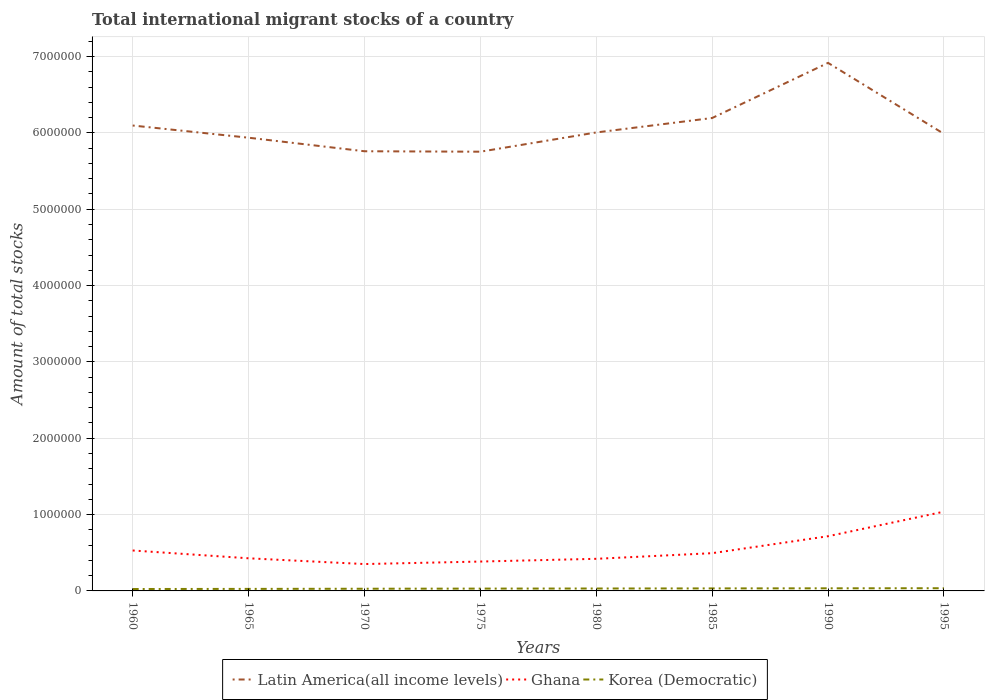Does the line corresponding to Korea (Democratic) intersect with the line corresponding to Latin America(all income levels)?
Offer a terse response. No. Across all years, what is the maximum amount of total stocks in in Korea (Democratic)?
Offer a very short reply. 2.51e+04. In which year was the amount of total stocks in in Korea (Democratic) maximum?
Your response must be concise. 1960. What is the total amount of total stocks in in Korea (Democratic) in the graph?
Your response must be concise. -1243. What is the difference between the highest and the second highest amount of total stocks in in Korea (Democratic)?
Your answer should be very brief. 1.02e+04. How many years are there in the graph?
Your response must be concise. 8. Where does the legend appear in the graph?
Your response must be concise. Bottom center. How many legend labels are there?
Keep it short and to the point. 3. What is the title of the graph?
Offer a terse response. Total international migrant stocks of a country. What is the label or title of the Y-axis?
Give a very brief answer. Amount of total stocks. What is the Amount of total stocks in Latin America(all income levels) in 1960?
Provide a short and direct response. 6.10e+06. What is the Amount of total stocks in Ghana in 1960?
Give a very brief answer. 5.30e+05. What is the Amount of total stocks in Korea (Democratic) in 1960?
Offer a terse response. 2.51e+04. What is the Amount of total stocks in Latin America(all income levels) in 1965?
Keep it short and to the point. 5.94e+06. What is the Amount of total stocks of Ghana in 1965?
Your response must be concise. 4.27e+05. What is the Amount of total stocks of Korea (Democratic) in 1965?
Your response must be concise. 2.66e+04. What is the Amount of total stocks of Latin America(all income levels) in 1970?
Keep it short and to the point. 5.76e+06. What is the Amount of total stocks of Ghana in 1970?
Keep it short and to the point. 3.52e+05. What is the Amount of total stocks in Korea (Democratic) in 1970?
Your answer should be very brief. 2.86e+04. What is the Amount of total stocks of Latin America(all income levels) in 1975?
Offer a very short reply. 5.75e+06. What is the Amount of total stocks of Ghana in 1975?
Give a very brief answer. 3.85e+05. What is the Amount of total stocks in Korea (Democratic) in 1975?
Give a very brief answer. 3.03e+04. What is the Amount of total stocks in Latin America(all income levels) in 1980?
Your answer should be very brief. 6.01e+06. What is the Amount of total stocks in Ghana in 1980?
Your answer should be compact. 4.21e+05. What is the Amount of total stocks in Korea (Democratic) in 1980?
Ensure brevity in your answer.  3.16e+04. What is the Amount of total stocks of Latin America(all income levels) in 1985?
Your answer should be very brief. 6.20e+06. What is the Amount of total stocks of Ghana in 1985?
Your answer should be very brief. 4.94e+05. What is the Amount of total stocks of Korea (Democratic) in 1985?
Your answer should be very brief. 3.29e+04. What is the Amount of total stocks in Latin America(all income levels) in 1990?
Make the answer very short. 6.92e+06. What is the Amount of total stocks of Ghana in 1990?
Your answer should be very brief. 7.17e+05. What is the Amount of total stocks of Korea (Democratic) in 1990?
Make the answer very short. 3.41e+04. What is the Amount of total stocks of Latin America(all income levels) in 1995?
Keep it short and to the point. 5.99e+06. What is the Amount of total stocks in Ghana in 1995?
Keep it short and to the point. 1.04e+06. What is the Amount of total stocks in Korea (Democratic) in 1995?
Your answer should be very brief. 3.53e+04. Across all years, what is the maximum Amount of total stocks in Latin America(all income levels)?
Give a very brief answer. 6.92e+06. Across all years, what is the maximum Amount of total stocks in Ghana?
Ensure brevity in your answer.  1.04e+06. Across all years, what is the maximum Amount of total stocks in Korea (Democratic)?
Your response must be concise. 3.53e+04. Across all years, what is the minimum Amount of total stocks of Latin America(all income levels)?
Give a very brief answer. 5.75e+06. Across all years, what is the minimum Amount of total stocks in Ghana?
Provide a succinct answer. 3.52e+05. Across all years, what is the minimum Amount of total stocks in Korea (Democratic)?
Ensure brevity in your answer.  2.51e+04. What is the total Amount of total stocks in Latin America(all income levels) in the graph?
Keep it short and to the point. 4.87e+07. What is the total Amount of total stocks in Ghana in the graph?
Keep it short and to the point. 4.36e+06. What is the total Amount of total stocks of Korea (Democratic) in the graph?
Your response must be concise. 2.44e+05. What is the difference between the Amount of total stocks in Latin America(all income levels) in 1960 and that in 1965?
Give a very brief answer. 1.60e+05. What is the difference between the Amount of total stocks in Ghana in 1960 and that in 1965?
Provide a short and direct response. 1.02e+05. What is the difference between the Amount of total stocks in Korea (Democratic) in 1960 and that in 1965?
Make the answer very short. -1524. What is the difference between the Amount of total stocks in Latin America(all income levels) in 1960 and that in 1970?
Keep it short and to the point. 3.37e+05. What is the difference between the Amount of total stocks in Ghana in 1960 and that in 1970?
Offer a terse response. 1.78e+05. What is the difference between the Amount of total stocks of Korea (Democratic) in 1960 and that in 1970?
Provide a succinct answer. -3496. What is the difference between the Amount of total stocks of Latin America(all income levels) in 1960 and that in 1975?
Keep it short and to the point. 3.43e+05. What is the difference between the Amount of total stocks of Ghana in 1960 and that in 1975?
Your response must be concise. 1.45e+05. What is the difference between the Amount of total stocks in Korea (Democratic) in 1960 and that in 1975?
Offer a terse response. -5273. What is the difference between the Amount of total stocks in Latin America(all income levels) in 1960 and that in 1980?
Keep it short and to the point. 9.09e+04. What is the difference between the Amount of total stocks of Ghana in 1960 and that in 1980?
Offer a terse response. 1.09e+05. What is the difference between the Amount of total stocks in Korea (Democratic) in 1960 and that in 1980?
Give a very brief answer. -6516. What is the difference between the Amount of total stocks in Latin America(all income levels) in 1960 and that in 1985?
Provide a succinct answer. -9.84e+04. What is the difference between the Amount of total stocks of Ghana in 1960 and that in 1985?
Keep it short and to the point. 3.53e+04. What is the difference between the Amount of total stocks in Korea (Democratic) in 1960 and that in 1985?
Keep it short and to the point. -7787. What is the difference between the Amount of total stocks of Latin America(all income levels) in 1960 and that in 1990?
Give a very brief answer. -8.21e+05. What is the difference between the Amount of total stocks in Ghana in 1960 and that in 1990?
Your response must be concise. -1.87e+05. What is the difference between the Amount of total stocks in Korea (Democratic) in 1960 and that in 1990?
Provide a succinct answer. -9031. What is the difference between the Amount of total stocks of Latin America(all income levels) in 1960 and that in 1995?
Provide a succinct answer. 1.09e+05. What is the difference between the Amount of total stocks in Ghana in 1960 and that in 1995?
Your answer should be compact. -5.09e+05. What is the difference between the Amount of total stocks of Korea (Democratic) in 1960 and that in 1995?
Keep it short and to the point. -1.02e+04. What is the difference between the Amount of total stocks of Latin America(all income levels) in 1965 and that in 1970?
Offer a very short reply. 1.77e+05. What is the difference between the Amount of total stocks in Ghana in 1965 and that in 1970?
Your response must be concise. 7.54e+04. What is the difference between the Amount of total stocks in Korea (Democratic) in 1965 and that in 1970?
Provide a succinct answer. -1972. What is the difference between the Amount of total stocks of Latin America(all income levels) in 1965 and that in 1975?
Keep it short and to the point. 1.83e+05. What is the difference between the Amount of total stocks in Ghana in 1965 and that in 1975?
Offer a terse response. 4.26e+04. What is the difference between the Amount of total stocks of Korea (Democratic) in 1965 and that in 1975?
Offer a very short reply. -3749. What is the difference between the Amount of total stocks in Latin America(all income levels) in 1965 and that in 1980?
Keep it short and to the point. -6.88e+04. What is the difference between the Amount of total stocks in Ghana in 1965 and that in 1980?
Offer a terse response. 6763. What is the difference between the Amount of total stocks of Korea (Democratic) in 1965 and that in 1980?
Provide a succinct answer. -4992. What is the difference between the Amount of total stocks in Latin America(all income levels) in 1965 and that in 1985?
Your answer should be compact. -2.58e+05. What is the difference between the Amount of total stocks of Ghana in 1965 and that in 1985?
Your response must be concise. -6.70e+04. What is the difference between the Amount of total stocks in Korea (Democratic) in 1965 and that in 1985?
Offer a terse response. -6263. What is the difference between the Amount of total stocks of Latin America(all income levels) in 1965 and that in 1990?
Offer a terse response. -9.80e+05. What is the difference between the Amount of total stocks of Ghana in 1965 and that in 1990?
Your response must be concise. -2.89e+05. What is the difference between the Amount of total stocks of Korea (Democratic) in 1965 and that in 1990?
Offer a terse response. -7507. What is the difference between the Amount of total stocks in Latin America(all income levels) in 1965 and that in 1995?
Provide a succinct answer. -5.05e+04. What is the difference between the Amount of total stocks in Ghana in 1965 and that in 1995?
Provide a succinct answer. -6.11e+05. What is the difference between the Amount of total stocks of Korea (Democratic) in 1965 and that in 1995?
Provide a succinct answer. -8695. What is the difference between the Amount of total stocks in Latin America(all income levels) in 1970 and that in 1975?
Keep it short and to the point. 5813. What is the difference between the Amount of total stocks in Ghana in 1970 and that in 1975?
Keep it short and to the point. -3.28e+04. What is the difference between the Amount of total stocks in Korea (Democratic) in 1970 and that in 1975?
Your answer should be compact. -1777. What is the difference between the Amount of total stocks in Latin America(all income levels) in 1970 and that in 1980?
Keep it short and to the point. -2.46e+05. What is the difference between the Amount of total stocks in Ghana in 1970 and that in 1980?
Offer a very short reply. -6.87e+04. What is the difference between the Amount of total stocks in Korea (Democratic) in 1970 and that in 1980?
Your response must be concise. -3020. What is the difference between the Amount of total stocks in Latin America(all income levels) in 1970 and that in 1985?
Your answer should be very brief. -4.36e+05. What is the difference between the Amount of total stocks of Ghana in 1970 and that in 1985?
Provide a succinct answer. -1.42e+05. What is the difference between the Amount of total stocks of Korea (Democratic) in 1970 and that in 1985?
Give a very brief answer. -4291. What is the difference between the Amount of total stocks in Latin America(all income levels) in 1970 and that in 1990?
Your answer should be very brief. -1.16e+06. What is the difference between the Amount of total stocks of Ghana in 1970 and that in 1990?
Your answer should be compact. -3.65e+05. What is the difference between the Amount of total stocks of Korea (Democratic) in 1970 and that in 1990?
Provide a succinct answer. -5535. What is the difference between the Amount of total stocks in Latin America(all income levels) in 1970 and that in 1995?
Make the answer very short. -2.28e+05. What is the difference between the Amount of total stocks of Ghana in 1970 and that in 1995?
Offer a terse response. -6.86e+05. What is the difference between the Amount of total stocks in Korea (Democratic) in 1970 and that in 1995?
Give a very brief answer. -6723. What is the difference between the Amount of total stocks of Latin America(all income levels) in 1975 and that in 1980?
Offer a terse response. -2.52e+05. What is the difference between the Amount of total stocks in Ghana in 1975 and that in 1980?
Give a very brief answer. -3.59e+04. What is the difference between the Amount of total stocks in Korea (Democratic) in 1975 and that in 1980?
Your answer should be compact. -1243. What is the difference between the Amount of total stocks in Latin America(all income levels) in 1975 and that in 1985?
Give a very brief answer. -4.41e+05. What is the difference between the Amount of total stocks of Ghana in 1975 and that in 1985?
Offer a terse response. -1.10e+05. What is the difference between the Amount of total stocks of Korea (Democratic) in 1975 and that in 1985?
Your answer should be compact. -2514. What is the difference between the Amount of total stocks of Latin America(all income levels) in 1975 and that in 1990?
Ensure brevity in your answer.  -1.16e+06. What is the difference between the Amount of total stocks in Ghana in 1975 and that in 1990?
Provide a succinct answer. -3.32e+05. What is the difference between the Amount of total stocks in Korea (Democratic) in 1975 and that in 1990?
Offer a very short reply. -3758. What is the difference between the Amount of total stocks in Latin America(all income levels) in 1975 and that in 1995?
Your answer should be compact. -2.34e+05. What is the difference between the Amount of total stocks of Ghana in 1975 and that in 1995?
Offer a very short reply. -6.54e+05. What is the difference between the Amount of total stocks of Korea (Democratic) in 1975 and that in 1995?
Your answer should be compact. -4946. What is the difference between the Amount of total stocks in Latin America(all income levels) in 1980 and that in 1985?
Ensure brevity in your answer.  -1.89e+05. What is the difference between the Amount of total stocks of Ghana in 1980 and that in 1985?
Give a very brief answer. -7.38e+04. What is the difference between the Amount of total stocks in Korea (Democratic) in 1980 and that in 1985?
Your answer should be very brief. -1271. What is the difference between the Amount of total stocks of Latin America(all income levels) in 1980 and that in 1990?
Provide a short and direct response. -9.11e+05. What is the difference between the Amount of total stocks in Ghana in 1980 and that in 1990?
Your answer should be compact. -2.96e+05. What is the difference between the Amount of total stocks in Korea (Democratic) in 1980 and that in 1990?
Provide a succinct answer. -2515. What is the difference between the Amount of total stocks of Latin America(all income levels) in 1980 and that in 1995?
Make the answer very short. 1.83e+04. What is the difference between the Amount of total stocks of Ghana in 1980 and that in 1995?
Provide a short and direct response. -6.18e+05. What is the difference between the Amount of total stocks in Korea (Democratic) in 1980 and that in 1995?
Offer a terse response. -3703. What is the difference between the Amount of total stocks in Latin America(all income levels) in 1985 and that in 1990?
Provide a succinct answer. -7.22e+05. What is the difference between the Amount of total stocks in Ghana in 1985 and that in 1990?
Offer a very short reply. -2.22e+05. What is the difference between the Amount of total stocks in Korea (Democratic) in 1985 and that in 1990?
Offer a very short reply. -1244. What is the difference between the Amount of total stocks of Latin America(all income levels) in 1985 and that in 1995?
Your answer should be very brief. 2.08e+05. What is the difference between the Amount of total stocks in Ghana in 1985 and that in 1995?
Give a very brief answer. -5.44e+05. What is the difference between the Amount of total stocks of Korea (Democratic) in 1985 and that in 1995?
Make the answer very short. -2432. What is the difference between the Amount of total stocks of Latin America(all income levels) in 1990 and that in 1995?
Provide a succinct answer. 9.30e+05. What is the difference between the Amount of total stocks in Ghana in 1990 and that in 1995?
Offer a terse response. -3.22e+05. What is the difference between the Amount of total stocks in Korea (Democratic) in 1990 and that in 1995?
Give a very brief answer. -1188. What is the difference between the Amount of total stocks in Latin America(all income levels) in 1960 and the Amount of total stocks in Ghana in 1965?
Make the answer very short. 5.67e+06. What is the difference between the Amount of total stocks in Latin America(all income levels) in 1960 and the Amount of total stocks in Korea (Democratic) in 1965?
Your answer should be very brief. 6.07e+06. What is the difference between the Amount of total stocks in Ghana in 1960 and the Amount of total stocks in Korea (Democratic) in 1965?
Offer a terse response. 5.03e+05. What is the difference between the Amount of total stocks of Latin America(all income levels) in 1960 and the Amount of total stocks of Ghana in 1970?
Make the answer very short. 5.74e+06. What is the difference between the Amount of total stocks of Latin America(all income levels) in 1960 and the Amount of total stocks of Korea (Democratic) in 1970?
Offer a terse response. 6.07e+06. What is the difference between the Amount of total stocks in Ghana in 1960 and the Amount of total stocks in Korea (Democratic) in 1970?
Offer a very short reply. 5.01e+05. What is the difference between the Amount of total stocks of Latin America(all income levels) in 1960 and the Amount of total stocks of Ghana in 1975?
Ensure brevity in your answer.  5.71e+06. What is the difference between the Amount of total stocks of Latin America(all income levels) in 1960 and the Amount of total stocks of Korea (Democratic) in 1975?
Keep it short and to the point. 6.07e+06. What is the difference between the Amount of total stocks of Ghana in 1960 and the Amount of total stocks of Korea (Democratic) in 1975?
Ensure brevity in your answer.  4.99e+05. What is the difference between the Amount of total stocks of Latin America(all income levels) in 1960 and the Amount of total stocks of Ghana in 1980?
Keep it short and to the point. 5.68e+06. What is the difference between the Amount of total stocks in Latin America(all income levels) in 1960 and the Amount of total stocks in Korea (Democratic) in 1980?
Provide a succinct answer. 6.07e+06. What is the difference between the Amount of total stocks in Ghana in 1960 and the Amount of total stocks in Korea (Democratic) in 1980?
Provide a short and direct response. 4.98e+05. What is the difference between the Amount of total stocks of Latin America(all income levels) in 1960 and the Amount of total stocks of Ghana in 1985?
Give a very brief answer. 5.60e+06. What is the difference between the Amount of total stocks in Latin America(all income levels) in 1960 and the Amount of total stocks in Korea (Democratic) in 1985?
Provide a succinct answer. 6.06e+06. What is the difference between the Amount of total stocks of Ghana in 1960 and the Amount of total stocks of Korea (Democratic) in 1985?
Your response must be concise. 4.97e+05. What is the difference between the Amount of total stocks in Latin America(all income levels) in 1960 and the Amount of total stocks in Ghana in 1990?
Ensure brevity in your answer.  5.38e+06. What is the difference between the Amount of total stocks of Latin America(all income levels) in 1960 and the Amount of total stocks of Korea (Democratic) in 1990?
Offer a terse response. 6.06e+06. What is the difference between the Amount of total stocks in Ghana in 1960 and the Amount of total stocks in Korea (Democratic) in 1990?
Your answer should be very brief. 4.96e+05. What is the difference between the Amount of total stocks of Latin America(all income levels) in 1960 and the Amount of total stocks of Ghana in 1995?
Give a very brief answer. 5.06e+06. What is the difference between the Amount of total stocks in Latin America(all income levels) in 1960 and the Amount of total stocks in Korea (Democratic) in 1995?
Ensure brevity in your answer.  6.06e+06. What is the difference between the Amount of total stocks in Ghana in 1960 and the Amount of total stocks in Korea (Democratic) in 1995?
Provide a succinct answer. 4.94e+05. What is the difference between the Amount of total stocks in Latin America(all income levels) in 1965 and the Amount of total stocks in Ghana in 1970?
Offer a very short reply. 5.59e+06. What is the difference between the Amount of total stocks in Latin America(all income levels) in 1965 and the Amount of total stocks in Korea (Democratic) in 1970?
Your answer should be compact. 5.91e+06. What is the difference between the Amount of total stocks in Ghana in 1965 and the Amount of total stocks in Korea (Democratic) in 1970?
Make the answer very short. 3.99e+05. What is the difference between the Amount of total stocks in Latin America(all income levels) in 1965 and the Amount of total stocks in Ghana in 1975?
Ensure brevity in your answer.  5.55e+06. What is the difference between the Amount of total stocks in Latin America(all income levels) in 1965 and the Amount of total stocks in Korea (Democratic) in 1975?
Your response must be concise. 5.91e+06. What is the difference between the Amount of total stocks in Ghana in 1965 and the Amount of total stocks in Korea (Democratic) in 1975?
Make the answer very short. 3.97e+05. What is the difference between the Amount of total stocks of Latin America(all income levels) in 1965 and the Amount of total stocks of Ghana in 1980?
Your answer should be compact. 5.52e+06. What is the difference between the Amount of total stocks in Latin America(all income levels) in 1965 and the Amount of total stocks in Korea (Democratic) in 1980?
Ensure brevity in your answer.  5.91e+06. What is the difference between the Amount of total stocks of Ghana in 1965 and the Amount of total stocks of Korea (Democratic) in 1980?
Provide a succinct answer. 3.96e+05. What is the difference between the Amount of total stocks in Latin America(all income levels) in 1965 and the Amount of total stocks in Ghana in 1985?
Your answer should be very brief. 5.44e+06. What is the difference between the Amount of total stocks in Latin America(all income levels) in 1965 and the Amount of total stocks in Korea (Democratic) in 1985?
Keep it short and to the point. 5.90e+06. What is the difference between the Amount of total stocks in Ghana in 1965 and the Amount of total stocks in Korea (Democratic) in 1985?
Ensure brevity in your answer.  3.95e+05. What is the difference between the Amount of total stocks in Latin America(all income levels) in 1965 and the Amount of total stocks in Ghana in 1990?
Your answer should be very brief. 5.22e+06. What is the difference between the Amount of total stocks of Latin America(all income levels) in 1965 and the Amount of total stocks of Korea (Democratic) in 1990?
Provide a succinct answer. 5.90e+06. What is the difference between the Amount of total stocks of Ghana in 1965 and the Amount of total stocks of Korea (Democratic) in 1990?
Your answer should be very brief. 3.93e+05. What is the difference between the Amount of total stocks in Latin America(all income levels) in 1965 and the Amount of total stocks in Ghana in 1995?
Your answer should be very brief. 4.90e+06. What is the difference between the Amount of total stocks of Latin America(all income levels) in 1965 and the Amount of total stocks of Korea (Democratic) in 1995?
Keep it short and to the point. 5.90e+06. What is the difference between the Amount of total stocks in Ghana in 1965 and the Amount of total stocks in Korea (Democratic) in 1995?
Provide a succinct answer. 3.92e+05. What is the difference between the Amount of total stocks of Latin America(all income levels) in 1970 and the Amount of total stocks of Ghana in 1975?
Your response must be concise. 5.37e+06. What is the difference between the Amount of total stocks of Latin America(all income levels) in 1970 and the Amount of total stocks of Korea (Democratic) in 1975?
Provide a short and direct response. 5.73e+06. What is the difference between the Amount of total stocks of Ghana in 1970 and the Amount of total stocks of Korea (Democratic) in 1975?
Your response must be concise. 3.22e+05. What is the difference between the Amount of total stocks in Latin America(all income levels) in 1970 and the Amount of total stocks in Ghana in 1980?
Provide a succinct answer. 5.34e+06. What is the difference between the Amount of total stocks in Latin America(all income levels) in 1970 and the Amount of total stocks in Korea (Democratic) in 1980?
Offer a terse response. 5.73e+06. What is the difference between the Amount of total stocks in Ghana in 1970 and the Amount of total stocks in Korea (Democratic) in 1980?
Offer a very short reply. 3.20e+05. What is the difference between the Amount of total stocks in Latin America(all income levels) in 1970 and the Amount of total stocks in Ghana in 1985?
Your response must be concise. 5.27e+06. What is the difference between the Amount of total stocks in Latin America(all income levels) in 1970 and the Amount of total stocks in Korea (Democratic) in 1985?
Offer a very short reply. 5.73e+06. What is the difference between the Amount of total stocks in Ghana in 1970 and the Amount of total stocks in Korea (Democratic) in 1985?
Keep it short and to the point. 3.19e+05. What is the difference between the Amount of total stocks in Latin America(all income levels) in 1970 and the Amount of total stocks in Ghana in 1990?
Keep it short and to the point. 5.04e+06. What is the difference between the Amount of total stocks in Latin America(all income levels) in 1970 and the Amount of total stocks in Korea (Democratic) in 1990?
Provide a short and direct response. 5.73e+06. What is the difference between the Amount of total stocks of Ghana in 1970 and the Amount of total stocks of Korea (Democratic) in 1990?
Provide a succinct answer. 3.18e+05. What is the difference between the Amount of total stocks of Latin America(all income levels) in 1970 and the Amount of total stocks of Ghana in 1995?
Provide a succinct answer. 4.72e+06. What is the difference between the Amount of total stocks of Latin America(all income levels) in 1970 and the Amount of total stocks of Korea (Democratic) in 1995?
Make the answer very short. 5.72e+06. What is the difference between the Amount of total stocks in Ghana in 1970 and the Amount of total stocks in Korea (Democratic) in 1995?
Provide a succinct answer. 3.17e+05. What is the difference between the Amount of total stocks of Latin America(all income levels) in 1975 and the Amount of total stocks of Ghana in 1980?
Keep it short and to the point. 5.33e+06. What is the difference between the Amount of total stocks in Latin America(all income levels) in 1975 and the Amount of total stocks in Korea (Democratic) in 1980?
Provide a short and direct response. 5.72e+06. What is the difference between the Amount of total stocks of Ghana in 1975 and the Amount of total stocks of Korea (Democratic) in 1980?
Your answer should be compact. 3.53e+05. What is the difference between the Amount of total stocks of Latin America(all income levels) in 1975 and the Amount of total stocks of Ghana in 1985?
Offer a very short reply. 5.26e+06. What is the difference between the Amount of total stocks of Latin America(all income levels) in 1975 and the Amount of total stocks of Korea (Democratic) in 1985?
Give a very brief answer. 5.72e+06. What is the difference between the Amount of total stocks of Ghana in 1975 and the Amount of total stocks of Korea (Democratic) in 1985?
Ensure brevity in your answer.  3.52e+05. What is the difference between the Amount of total stocks in Latin America(all income levels) in 1975 and the Amount of total stocks in Ghana in 1990?
Provide a succinct answer. 5.04e+06. What is the difference between the Amount of total stocks in Latin America(all income levels) in 1975 and the Amount of total stocks in Korea (Democratic) in 1990?
Give a very brief answer. 5.72e+06. What is the difference between the Amount of total stocks of Ghana in 1975 and the Amount of total stocks of Korea (Democratic) in 1990?
Provide a short and direct response. 3.51e+05. What is the difference between the Amount of total stocks of Latin America(all income levels) in 1975 and the Amount of total stocks of Ghana in 1995?
Make the answer very short. 4.72e+06. What is the difference between the Amount of total stocks in Latin America(all income levels) in 1975 and the Amount of total stocks in Korea (Democratic) in 1995?
Provide a short and direct response. 5.72e+06. What is the difference between the Amount of total stocks in Ghana in 1975 and the Amount of total stocks in Korea (Democratic) in 1995?
Give a very brief answer. 3.49e+05. What is the difference between the Amount of total stocks in Latin America(all income levels) in 1980 and the Amount of total stocks in Ghana in 1985?
Your answer should be compact. 5.51e+06. What is the difference between the Amount of total stocks of Latin America(all income levels) in 1980 and the Amount of total stocks of Korea (Democratic) in 1985?
Your answer should be compact. 5.97e+06. What is the difference between the Amount of total stocks in Ghana in 1980 and the Amount of total stocks in Korea (Democratic) in 1985?
Offer a very short reply. 3.88e+05. What is the difference between the Amount of total stocks of Latin America(all income levels) in 1980 and the Amount of total stocks of Ghana in 1990?
Ensure brevity in your answer.  5.29e+06. What is the difference between the Amount of total stocks of Latin America(all income levels) in 1980 and the Amount of total stocks of Korea (Democratic) in 1990?
Make the answer very short. 5.97e+06. What is the difference between the Amount of total stocks in Ghana in 1980 and the Amount of total stocks in Korea (Democratic) in 1990?
Your answer should be very brief. 3.87e+05. What is the difference between the Amount of total stocks in Latin America(all income levels) in 1980 and the Amount of total stocks in Ghana in 1995?
Provide a short and direct response. 4.97e+06. What is the difference between the Amount of total stocks in Latin America(all income levels) in 1980 and the Amount of total stocks in Korea (Democratic) in 1995?
Give a very brief answer. 5.97e+06. What is the difference between the Amount of total stocks of Ghana in 1980 and the Amount of total stocks of Korea (Democratic) in 1995?
Keep it short and to the point. 3.85e+05. What is the difference between the Amount of total stocks in Latin America(all income levels) in 1985 and the Amount of total stocks in Ghana in 1990?
Provide a short and direct response. 5.48e+06. What is the difference between the Amount of total stocks of Latin America(all income levels) in 1985 and the Amount of total stocks of Korea (Democratic) in 1990?
Provide a succinct answer. 6.16e+06. What is the difference between the Amount of total stocks in Ghana in 1985 and the Amount of total stocks in Korea (Democratic) in 1990?
Your answer should be compact. 4.60e+05. What is the difference between the Amount of total stocks in Latin America(all income levels) in 1985 and the Amount of total stocks in Ghana in 1995?
Your response must be concise. 5.16e+06. What is the difference between the Amount of total stocks of Latin America(all income levels) in 1985 and the Amount of total stocks of Korea (Democratic) in 1995?
Your response must be concise. 6.16e+06. What is the difference between the Amount of total stocks in Ghana in 1985 and the Amount of total stocks in Korea (Democratic) in 1995?
Provide a short and direct response. 4.59e+05. What is the difference between the Amount of total stocks in Latin America(all income levels) in 1990 and the Amount of total stocks in Ghana in 1995?
Make the answer very short. 5.88e+06. What is the difference between the Amount of total stocks of Latin America(all income levels) in 1990 and the Amount of total stocks of Korea (Democratic) in 1995?
Make the answer very short. 6.88e+06. What is the difference between the Amount of total stocks of Ghana in 1990 and the Amount of total stocks of Korea (Democratic) in 1995?
Provide a succinct answer. 6.81e+05. What is the average Amount of total stocks of Latin America(all income levels) per year?
Your response must be concise. 6.08e+06. What is the average Amount of total stocks of Ghana per year?
Make the answer very short. 5.45e+05. What is the average Amount of total stocks in Korea (Democratic) per year?
Make the answer very short. 3.06e+04. In the year 1960, what is the difference between the Amount of total stocks of Latin America(all income levels) and Amount of total stocks of Ghana?
Give a very brief answer. 5.57e+06. In the year 1960, what is the difference between the Amount of total stocks of Latin America(all income levels) and Amount of total stocks of Korea (Democratic)?
Give a very brief answer. 6.07e+06. In the year 1960, what is the difference between the Amount of total stocks in Ghana and Amount of total stocks in Korea (Democratic)?
Your response must be concise. 5.05e+05. In the year 1965, what is the difference between the Amount of total stocks of Latin America(all income levels) and Amount of total stocks of Ghana?
Your response must be concise. 5.51e+06. In the year 1965, what is the difference between the Amount of total stocks of Latin America(all income levels) and Amount of total stocks of Korea (Democratic)?
Keep it short and to the point. 5.91e+06. In the year 1965, what is the difference between the Amount of total stocks of Ghana and Amount of total stocks of Korea (Democratic)?
Your answer should be compact. 4.01e+05. In the year 1970, what is the difference between the Amount of total stocks of Latin America(all income levels) and Amount of total stocks of Ghana?
Make the answer very short. 5.41e+06. In the year 1970, what is the difference between the Amount of total stocks of Latin America(all income levels) and Amount of total stocks of Korea (Democratic)?
Offer a very short reply. 5.73e+06. In the year 1970, what is the difference between the Amount of total stocks in Ghana and Amount of total stocks in Korea (Democratic)?
Your answer should be very brief. 3.23e+05. In the year 1975, what is the difference between the Amount of total stocks in Latin America(all income levels) and Amount of total stocks in Ghana?
Your answer should be very brief. 5.37e+06. In the year 1975, what is the difference between the Amount of total stocks of Latin America(all income levels) and Amount of total stocks of Korea (Democratic)?
Your response must be concise. 5.72e+06. In the year 1975, what is the difference between the Amount of total stocks in Ghana and Amount of total stocks in Korea (Democratic)?
Provide a succinct answer. 3.54e+05. In the year 1980, what is the difference between the Amount of total stocks in Latin America(all income levels) and Amount of total stocks in Ghana?
Offer a terse response. 5.59e+06. In the year 1980, what is the difference between the Amount of total stocks of Latin America(all income levels) and Amount of total stocks of Korea (Democratic)?
Make the answer very short. 5.97e+06. In the year 1980, what is the difference between the Amount of total stocks of Ghana and Amount of total stocks of Korea (Democratic)?
Make the answer very short. 3.89e+05. In the year 1985, what is the difference between the Amount of total stocks in Latin America(all income levels) and Amount of total stocks in Ghana?
Keep it short and to the point. 5.70e+06. In the year 1985, what is the difference between the Amount of total stocks in Latin America(all income levels) and Amount of total stocks in Korea (Democratic)?
Your answer should be compact. 6.16e+06. In the year 1985, what is the difference between the Amount of total stocks in Ghana and Amount of total stocks in Korea (Democratic)?
Your answer should be very brief. 4.62e+05. In the year 1990, what is the difference between the Amount of total stocks in Latin America(all income levels) and Amount of total stocks in Ghana?
Provide a short and direct response. 6.20e+06. In the year 1990, what is the difference between the Amount of total stocks of Latin America(all income levels) and Amount of total stocks of Korea (Democratic)?
Your answer should be very brief. 6.88e+06. In the year 1990, what is the difference between the Amount of total stocks of Ghana and Amount of total stocks of Korea (Democratic)?
Provide a short and direct response. 6.82e+05. In the year 1995, what is the difference between the Amount of total stocks of Latin America(all income levels) and Amount of total stocks of Ghana?
Keep it short and to the point. 4.95e+06. In the year 1995, what is the difference between the Amount of total stocks in Latin America(all income levels) and Amount of total stocks in Korea (Democratic)?
Make the answer very short. 5.95e+06. In the year 1995, what is the difference between the Amount of total stocks of Ghana and Amount of total stocks of Korea (Democratic)?
Your response must be concise. 1.00e+06. What is the ratio of the Amount of total stocks of Latin America(all income levels) in 1960 to that in 1965?
Make the answer very short. 1.03. What is the ratio of the Amount of total stocks of Ghana in 1960 to that in 1965?
Offer a terse response. 1.24. What is the ratio of the Amount of total stocks in Korea (Democratic) in 1960 to that in 1965?
Your answer should be very brief. 0.94. What is the ratio of the Amount of total stocks of Latin America(all income levels) in 1960 to that in 1970?
Give a very brief answer. 1.06. What is the ratio of the Amount of total stocks of Ghana in 1960 to that in 1970?
Your answer should be compact. 1.5. What is the ratio of the Amount of total stocks of Korea (Democratic) in 1960 to that in 1970?
Offer a very short reply. 0.88. What is the ratio of the Amount of total stocks in Latin America(all income levels) in 1960 to that in 1975?
Your answer should be compact. 1.06. What is the ratio of the Amount of total stocks in Ghana in 1960 to that in 1975?
Keep it short and to the point. 1.38. What is the ratio of the Amount of total stocks in Korea (Democratic) in 1960 to that in 1975?
Keep it short and to the point. 0.83. What is the ratio of the Amount of total stocks in Latin America(all income levels) in 1960 to that in 1980?
Provide a short and direct response. 1.02. What is the ratio of the Amount of total stocks of Ghana in 1960 to that in 1980?
Give a very brief answer. 1.26. What is the ratio of the Amount of total stocks in Korea (Democratic) in 1960 to that in 1980?
Provide a succinct answer. 0.79. What is the ratio of the Amount of total stocks of Latin America(all income levels) in 1960 to that in 1985?
Your answer should be compact. 0.98. What is the ratio of the Amount of total stocks in Ghana in 1960 to that in 1985?
Your answer should be very brief. 1.07. What is the ratio of the Amount of total stocks of Korea (Democratic) in 1960 to that in 1985?
Your answer should be compact. 0.76. What is the ratio of the Amount of total stocks of Latin America(all income levels) in 1960 to that in 1990?
Provide a succinct answer. 0.88. What is the ratio of the Amount of total stocks in Ghana in 1960 to that in 1990?
Provide a succinct answer. 0.74. What is the ratio of the Amount of total stocks of Korea (Democratic) in 1960 to that in 1990?
Ensure brevity in your answer.  0.74. What is the ratio of the Amount of total stocks in Latin America(all income levels) in 1960 to that in 1995?
Your response must be concise. 1.02. What is the ratio of the Amount of total stocks of Ghana in 1960 to that in 1995?
Offer a terse response. 0.51. What is the ratio of the Amount of total stocks of Korea (Democratic) in 1960 to that in 1995?
Provide a succinct answer. 0.71. What is the ratio of the Amount of total stocks in Latin America(all income levels) in 1965 to that in 1970?
Keep it short and to the point. 1.03. What is the ratio of the Amount of total stocks in Ghana in 1965 to that in 1970?
Provide a short and direct response. 1.21. What is the ratio of the Amount of total stocks in Latin America(all income levels) in 1965 to that in 1975?
Offer a very short reply. 1.03. What is the ratio of the Amount of total stocks in Ghana in 1965 to that in 1975?
Your answer should be very brief. 1.11. What is the ratio of the Amount of total stocks in Korea (Democratic) in 1965 to that in 1975?
Your answer should be compact. 0.88. What is the ratio of the Amount of total stocks in Ghana in 1965 to that in 1980?
Ensure brevity in your answer.  1.02. What is the ratio of the Amount of total stocks of Korea (Democratic) in 1965 to that in 1980?
Provide a succinct answer. 0.84. What is the ratio of the Amount of total stocks of Ghana in 1965 to that in 1985?
Your response must be concise. 0.86. What is the ratio of the Amount of total stocks in Korea (Democratic) in 1965 to that in 1985?
Offer a very short reply. 0.81. What is the ratio of the Amount of total stocks of Latin America(all income levels) in 1965 to that in 1990?
Make the answer very short. 0.86. What is the ratio of the Amount of total stocks in Ghana in 1965 to that in 1990?
Your answer should be compact. 0.6. What is the ratio of the Amount of total stocks of Korea (Democratic) in 1965 to that in 1990?
Your response must be concise. 0.78. What is the ratio of the Amount of total stocks of Latin America(all income levels) in 1965 to that in 1995?
Ensure brevity in your answer.  0.99. What is the ratio of the Amount of total stocks in Ghana in 1965 to that in 1995?
Your answer should be very brief. 0.41. What is the ratio of the Amount of total stocks of Korea (Democratic) in 1965 to that in 1995?
Ensure brevity in your answer.  0.75. What is the ratio of the Amount of total stocks in Ghana in 1970 to that in 1975?
Ensure brevity in your answer.  0.91. What is the ratio of the Amount of total stocks in Korea (Democratic) in 1970 to that in 1975?
Give a very brief answer. 0.94. What is the ratio of the Amount of total stocks in Latin America(all income levels) in 1970 to that in 1980?
Make the answer very short. 0.96. What is the ratio of the Amount of total stocks in Ghana in 1970 to that in 1980?
Your response must be concise. 0.84. What is the ratio of the Amount of total stocks of Korea (Democratic) in 1970 to that in 1980?
Ensure brevity in your answer.  0.9. What is the ratio of the Amount of total stocks of Latin America(all income levels) in 1970 to that in 1985?
Offer a very short reply. 0.93. What is the ratio of the Amount of total stocks of Ghana in 1970 to that in 1985?
Offer a very short reply. 0.71. What is the ratio of the Amount of total stocks in Korea (Democratic) in 1970 to that in 1985?
Your answer should be compact. 0.87. What is the ratio of the Amount of total stocks of Latin America(all income levels) in 1970 to that in 1990?
Provide a short and direct response. 0.83. What is the ratio of the Amount of total stocks of Ghana in 1970 to that in 1990?
Give a very brief answer. 0.49. What is the ratio of the Amount of total stocks of Korea (Democratic) in 1970 to that in 1990?
Provide a short and direct response. 0.84. What is the ratio of the Amount of total stocks in Latin America(all income levels) in 1970 to that in 1995?
Offer a very short reply. 0.96. What is the ratio of the Amount of total stocks of Ghana in 1970 to that in 1995?
Give a very brief answer. 0.34. What is the ratio of the Amount of total stocks in Korea (Democratic) in 1970 to that in 1995?
Your response must be concise. 0.81. What is the ratio of the Amount of total stocks of Latin America(all income levels) in 1975 to that in 1980?
Offer a terse response. 0.96. What is the ratio of the Amount of total stocks of Ghana in 1975 to that in 1980?
Offer a very short reply. 0.91. What is the ratio of the Amount of total stocks of Korea (Democratic) in 1975 to that in 1980?
Your answer should be compact. 0.96. What is the ratio of the Amount of total stocks in Latin America(all income levels) in 1975 to that in 1985?
Your response must be concise. 0.93. What is the ratio of the Amount of total stocks of Ghana in 1975 to that in 1985?
Keep it short and to the point. 0.78. What is the ratio of the Amount of total stocks of Korea (Democratic) in 1975 to that in 1985?
Your response must be concise. 0.92. What is the ratio of the Amount of total stocks of Latin America(all income levels) in 1975 to that in 1990?
Keep it short and to the point. 0.83. What is the ratio of the Amount of total stocks in Ghana in 1975 to that in 1990?
Provide a short and direct response. 0.54. What is the ratio of the Amount of total stocks of Korea (Democratic) in 1975 to that in 1990?
Provide a succinct answer. 0.89. What is the ratio of the Amount of total stocks in Ghana in 1975 to that in 1995?
Offer a terse response. 0.37. What is the ratio of the Amount of total stocks in Korea (Democratic) in 1975 to that in 1995?
Offer a very short reply. 0.86. What is the ratio of the Amount of total stocks of Latin America(all income levels) in 1980 to that in 1985?
Ensure brevity in your answer.  0.97. What is the ratio of the Amount of total stocks in Ghana in 1980 to that in 1985?
Give a very brief answer. 0.85. What is the ratio of the Amount of total stocks of Korea (Democratic) in 1980 to that in 1985?
Give a very brief answer. 0.96. What is the ratio of the Amount of total stocks of Latin America(all income levels) in 1980 to that in 1990?
Ensure brevity in your answer.  0.87. What is the ratio of the Amount of total stocks of Ghana in 1980 to that in 1990?
Provide a short and direct response. 0.59. What is the ratio of the Amount of total stocks of Korea (Democratic) in 1980 to that in 1990?
Offer a very short reply. 0.93. What is the ratio of the Amount of total stocks in Ghana in 1980 to that in 1995?
Keep it short and to the point. 0.41. What is the ratio of the Amount of total stocks of Korea (Democratic) in 1980 to that in 1995?
Your answer should be very brief. 0.9. What is the ratio of the Amount of total stocks in Latin America(all income levels) in 1985 to that in 1990?
Your answer should be compact. 0.9. What is the ratio of the Amount of total stocks of Ghana in 1985 to that in 1990?
Your answer should be very brief. 0.69. What is the ratio of the Amount of total stocks in Korea (Democratic) in 1985 to that in 1990?
Your response must be concise. 0.96. What is the ratio of the Amount of total stocks of Latin America(all income levels) in 1985 to that in 1995?
Ensure brevity in your answer.  1.03. What is the ratio of the Amount of total stocks in Ghana in 1985 to that in 1995?
Your answer should be compact. 0.48. What is the ratio of the Amount of total stocks of Korea (Democratic) in 1985 to that in 1995?
Your response must be concise. 0.93. What is the ratio of the Amount of total stocks of Latin America(all income levels) in 1990 to that in 1995?
Provide a short and direct response. 1.16. What is the ratio of the Amount of total stocks of Ghana in 1990 to that in 1995?
Provide a succinct answer. 0.69. What is the ratio of the Amount of total stocks of Korea (Democratic) in 1990 to that in 1995?
Offer a terse response. 0.97. What is the difference between the highest and the second highest Amount of total stocks in Latin America(all income levels)?
Your answer should be compact. 7.22e+05. What is the difference between the highest and the second highest Amount of total stocks in Ghana?
Provide a short and direct response. 3.22e+05. What is the difference between the highest and the second highest Amount of total stocks in Korea (Democratic)?
Your response must be concise. 1188. What is the difference between the highest and the lowest Amount of total stocks in Latin America(all income levels)?
Make the answer very short. 1.16e+06. What is the difference between the highest and the lowest Amount of total stocks in Ghana?
Provide a succinct answer. 6.86e+05. What is the difference between the highest and the lowest Amount of total stocks in Korea (Democratic)?
Offer a terse response. 1.02e+04. 